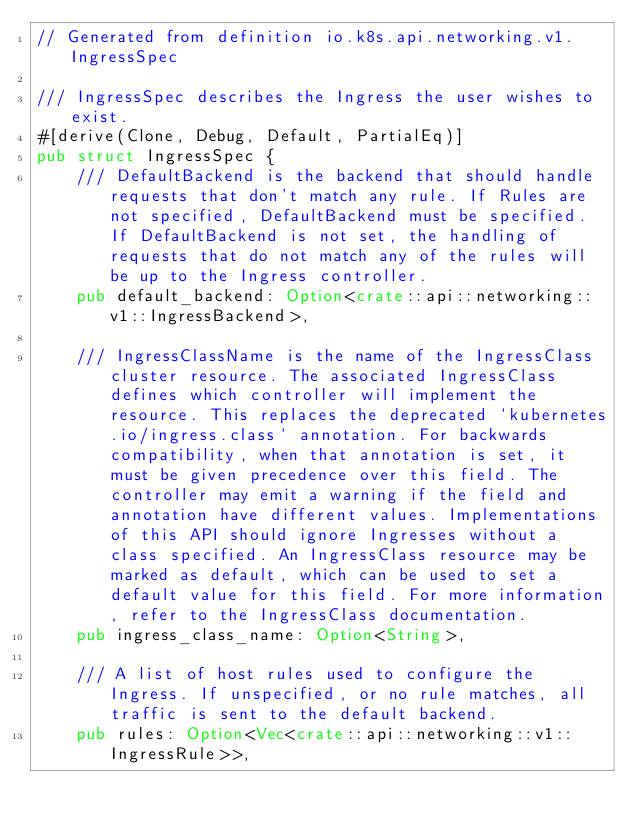<code> <loc_0><loc_0><loc_500><loc_500><_Rust_>// Generated from definition io.k8s.api.networking.v1.IngressSpec

/// IngressSpec describes the Ingress the user wishes to exist.
#[derive(Clone, Debug, Default, PartialEq)]
pub struct IngressSpec {
    /// DefaultBackend is the backend that should handle requests that don't match any rule. If Rules are not specified, DefaultBackend must be specified. If DefaultBackend is not set, the handling of requests that do not match any of the rules will be up to the Ingress controller.
    pub default_backend: Option<crate::api::networking::v1::IngressBackend>,

    /// IngressClassName is the name of the IngressClass cluster resource. The associated IngressClass defines which controller will implement the resource. This replaces the deprecated `kubernetes.io/ingress.class` annotation. For backwards compatibility, when that annotation is set, it must be given precedence over this field. The controller may emit a warning if the field and annotation have different values. Implementations of this API should ignore Ingresses without a class specified. An IngressClass resource may be marked as default, which can be used to set a default value for this field. For more information, refer to the IngressClass documentation.
    pub ingress_class_name: Option<String>,

    /// A list of host rules used to configure the Ingress. If unspecified, or no rule matches, all traffic is sent to the default backend.
    pub rules: Option<Vec<crate::api::networking::v1::IngressRule>>,
</code> 